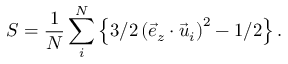<formula> <loc_0><loc_0><loc_500><loc_500>S = \frac { 1 } { N } \sum _ { i } ^ { N } \left \{ 3 / 2 \left ( \vec { e } _ { z } \cdot \vec { u } _ { i } \right ) ^ { 2 } - 1 / 2 \right \} .</formula> 